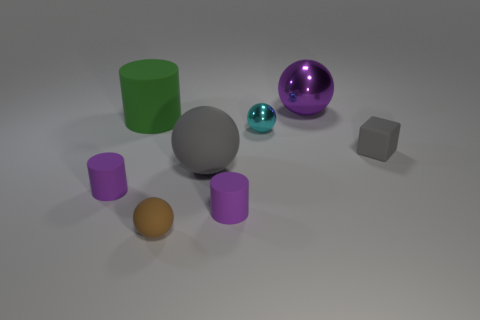Add 2 purple rubber cylinders. How many objects exist? 10 Subtract all cylinders. How many objects are left? 5 Add 7 big green objects. How many big green objects are left? 8 Add 2 cyan spheres. How many cyan spheres exist? 3 Subtract 1 cyan balls. How many objects are left? 7 Subtract all metal spheres. Subtract all gray rubber spheres. How many objects are left? 5 